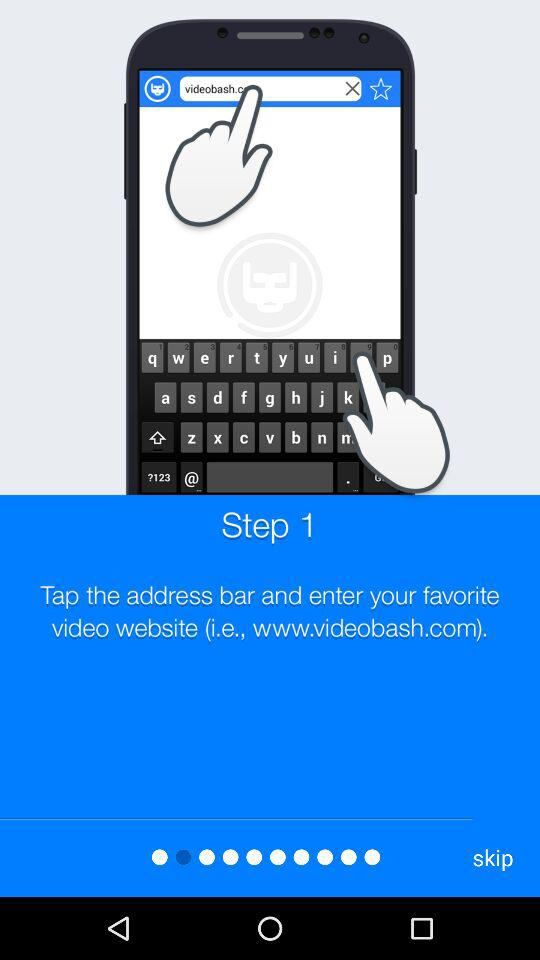What is the website? The website is www.videobash.com. 